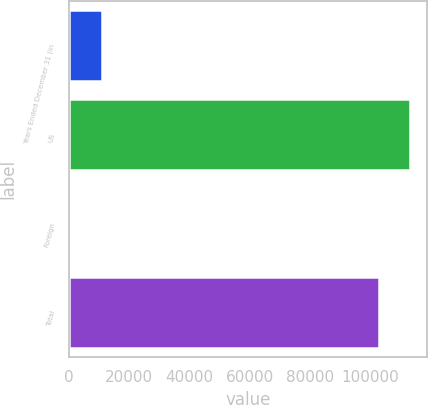<chart> <loc_0><loc_0><loc_500><loc_500><bar_chart><fcel>Years Ended December 31 (in<fcel>US<fcel>Foreign<fcel>Total<nl><fcel>10825.9<fcel>113332<fcel>523<fcel>103029<nl></chart> 